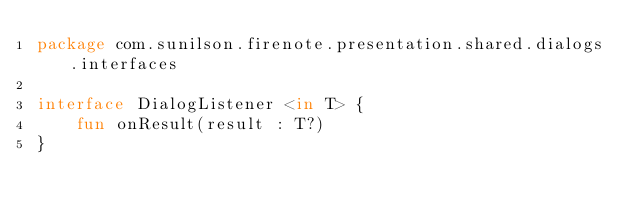Convert code to text. <code><loc_0><loc_0><loc_500><loc_500><_Kotlin_>package com.sunilson.firenote.presentation.shared.dialogs.interfaces

interface DialogListener <in T> {
    fun onResult(result : T?)
}</code> 